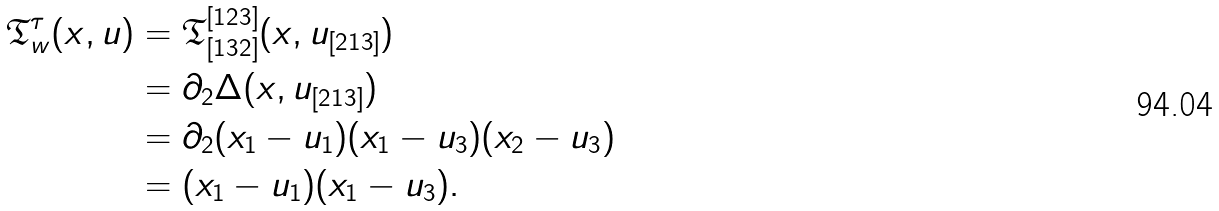Convert formula to latex. <formula><loc_0><loc_0><loc_500><loc_500>\mathfrak { T } _ { w } ^ { \tau } ( x , u ) & = \mathfrak { T } _ { [ 1 3 2 ] } ^ { [ 1 2 3 ] } ( x , u _ { [ 2 1 3 ] } ) \\ & = \partial _ { 2 } \Delta ( x , u _ { [ 2 1 3 ] } ) \\ & = \partial _ { 2 } ( x _ { 1 } - u _ { 1 } ) ( x _ { 1 } - u _ { 3 } ) ( x _ { 2 } - u _ { 3 } ) \\ & = ( x _ { 1 } - u _ { 1 } ) ( x _ { 1 } - u _ { 3 } ) .</formula> 